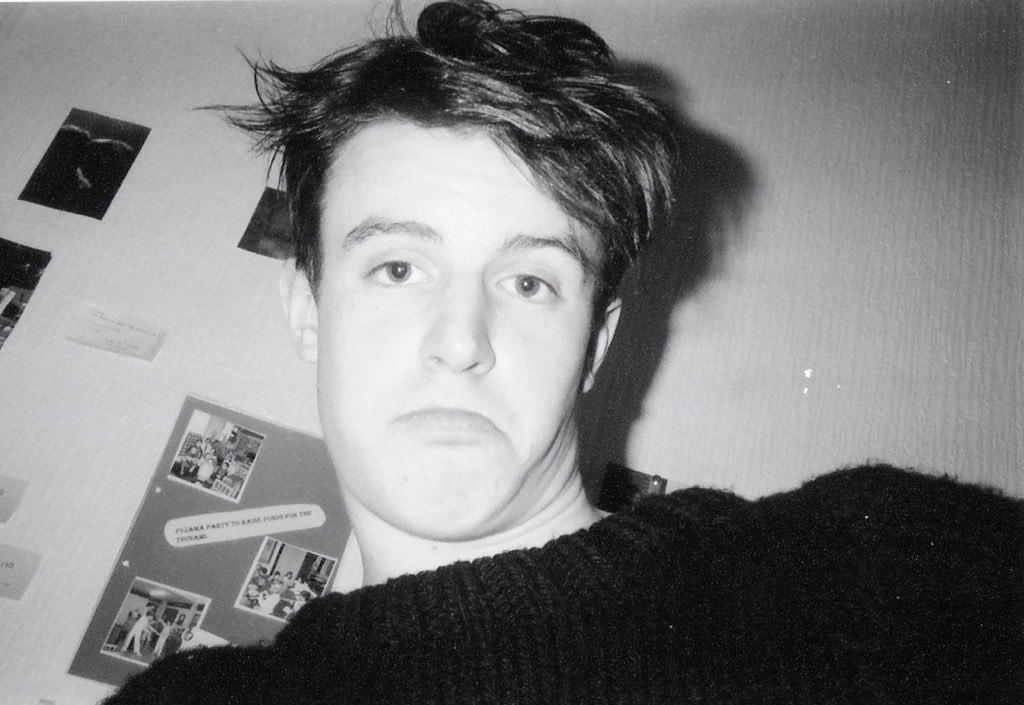Who is the main subject in the image? There is a man in the center of the image. What is the man wearing? The man is wearing a black shirt. What can be seen in the background of the image? There is a wall in the background of the image. What is on the wall in the background? Photos are placed on the wall in the background. What disease is the man suffering from in the image? There is no indication of any disease in the image; it only shows a man wearing a black shirt with a wall and photos in the background. 